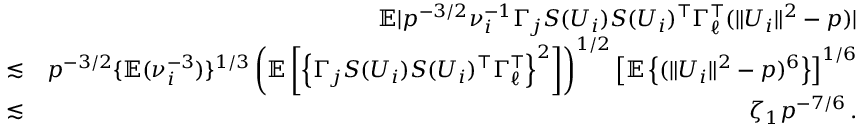<formula> <loc_0><loc_0><loc_500><loc_500>\begin{array} { r l r } & { { \mathbb { E } } | p ^ { - 3 / 2 } \nu _ { i } ^ { - 1 } \Gamma _ { j } S ( U _ { i } ) S ( U _ { i } ) ^ { \top } \Gamma _ { \ell } ^ { \top } ( \| U _ { i } \| ^ { 2 } - p ) | } \\ & { \lesssim } & { p ^ { - 3 / 2 } \{ { \mathbb { E } } ( \nu _ { i } ^ { - 3 } ) \} ^ { 1 / 3 } \left ( { \mathbb { E } } \left [ \left \{ \Gamma _ { j } S ( U _ { i } ) S ( U _ { i } ) ^ { \top } \Gamma _ { \ell } ^ { \top } \right \} ^ { 2 } \right ] \right ) ^ { 1 / 2 } \left [ { \mathbb { E } } \left \{ ( \| U _ { i } \| ^ { 2 } - p ) ^ { 6 } \right \} \right ] ^ { 1 / 6 } } \\ & { \lesssim } & { \zeta _ { 1 } p ^ { - 7 / 6 } \, . } \end{array}</formula> 